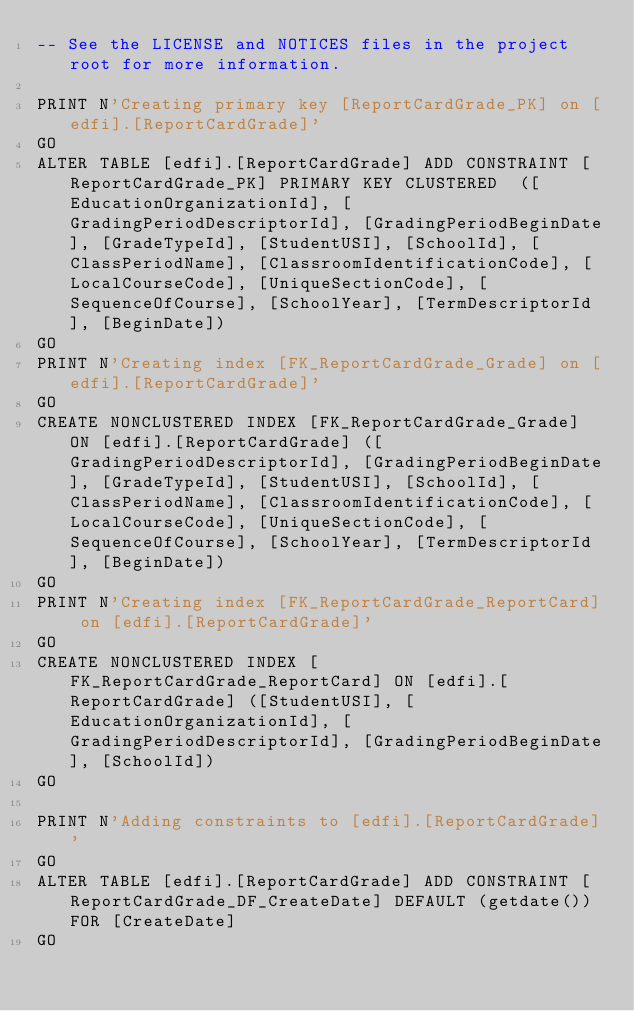Convert code to text. <code><loc_0><loc_0><loc_500><loc_500><_SQL_>-- See the LICENSE and NOTICES files in the project root for more information.

PRINT N'Creating primary key [ReportCardGrade_PK] on [edfi].[ReportCardGrade]'
GO
ALTER TABLE [edfi].[ReportCardGrade] ADD CONSTRAINT [ReportCardGrade_PK] PRIMARY KEY CLUSTERED  ([EducationOrganizationId], [GradingPeriodDescriptorId], [GradingPeriodBeginDate], [GradeTypeId], [StudentUSI], [SchoolId], [ClassPeriodName], [ClassroomIdentificationCode], [LocalCourseCode], [UniqueSectionCode], [SequenceOfCourse], [SchoolYear], [TermDescriptorId], [BeginDate])
GO
PRINT N'Creating index [FK_ReportCardGrade_Grade] on [edfi].[ReportCardGrade]'
GO
CREATE NONCLUSTERED INDEX [FK_ReportCardGrade_Grade] ON [edfi].[ReportCardGrade] ([GradingPeriodDescriptorId], [GradingPeriodBeginDate], [GradeTypeId], [StudentUSI], [SchoolId], [ClassPeriodName], [ClassroomIdentificationCode], [LocalCourseCode], [UniqueSectionCode], [SequenceOfCourse], [SchoolYear], [TermDescriptorId], [BeginDate])
GO
PRINT N'Creating index [FK_ReportCardGrade_ReportCard] on [edfi].[ReportCardGrade]'
GO
CREATE NONCLUSTERED INDEX [FK_ReportCardGrade_ReportCard] ON [edfi].[ReportCardGrade] ([StudentUSI], [EducationOrganizationId], [GradingPeriodDescriptorId], [GradingPeriodBeginDate], [SchoolId])
GO

PRINT N'Adding constraints to [edfi].[ReportCardGrade]'
GO
ALTER TABLE [edfi].[ReportCardGrade] ADD CONSTRAINT [ReportCardGrade_DF_CreateDate] DEFAULT (getdate()) FOR [CreateDate]
GO

</code> 